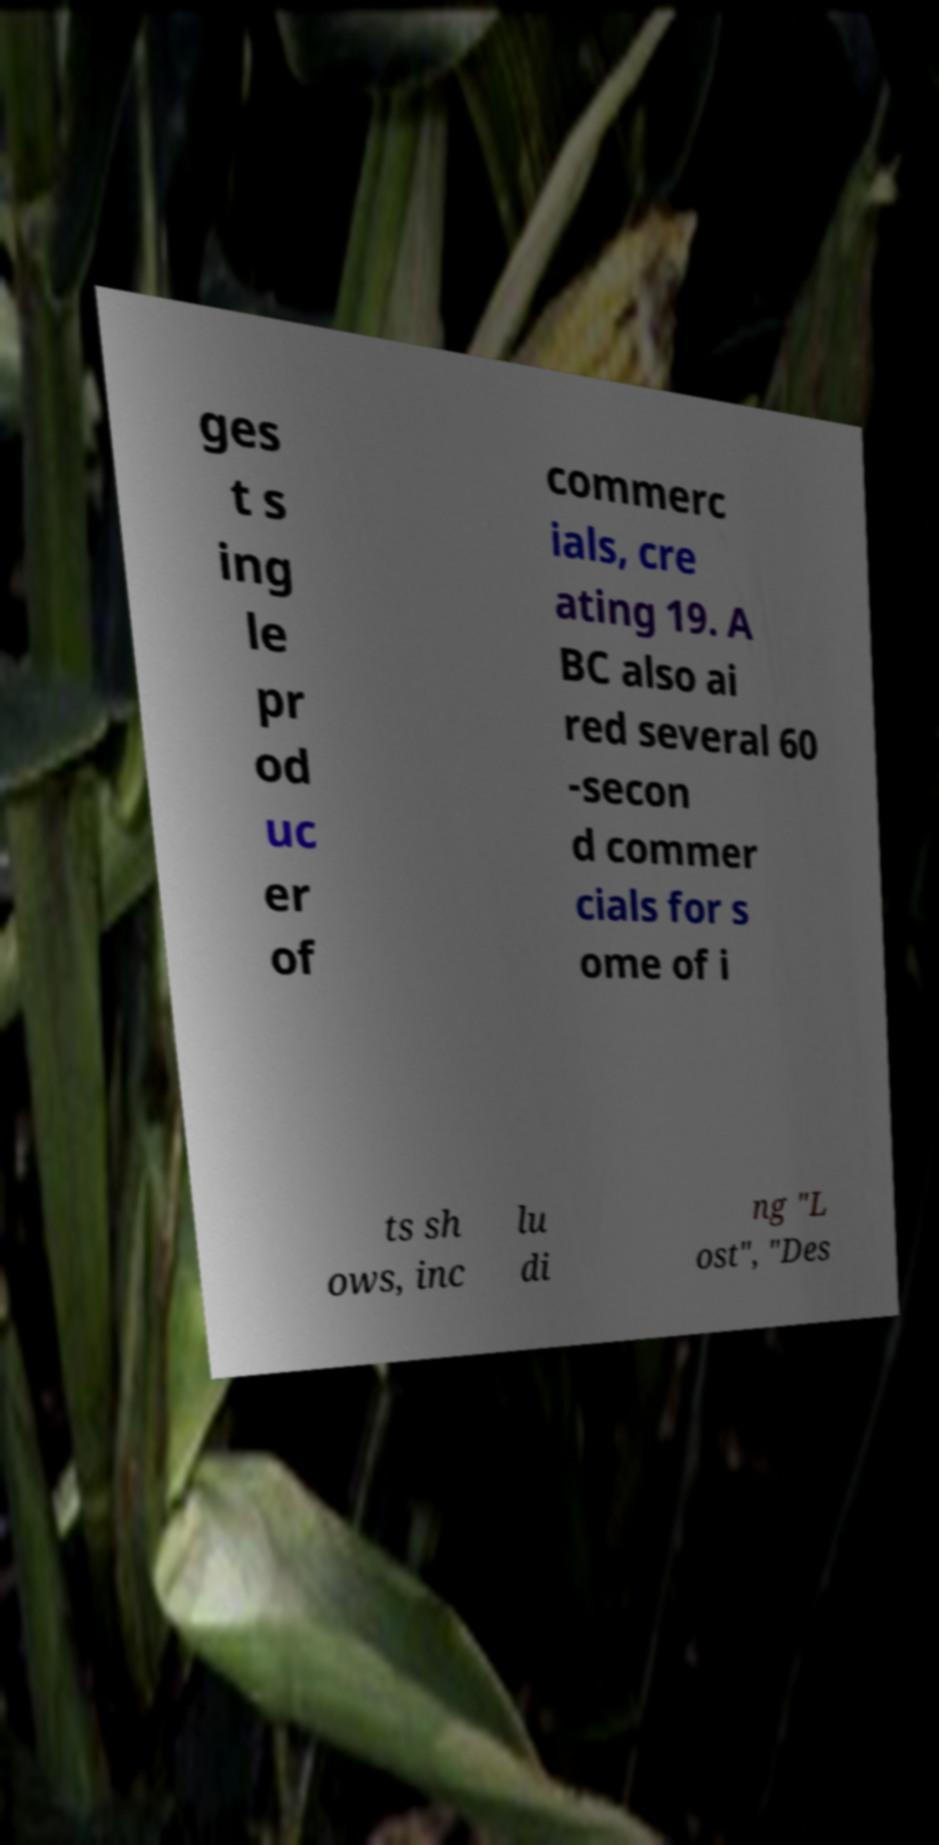Could you extract and type out the text from this image? ges t s ing le pr od uc er of commerc ials, cre ating 19. A BC also ai red several 60 -secon d commer cials for s ome of i ts sh ows, inc lu di ng "L ost", "Des 